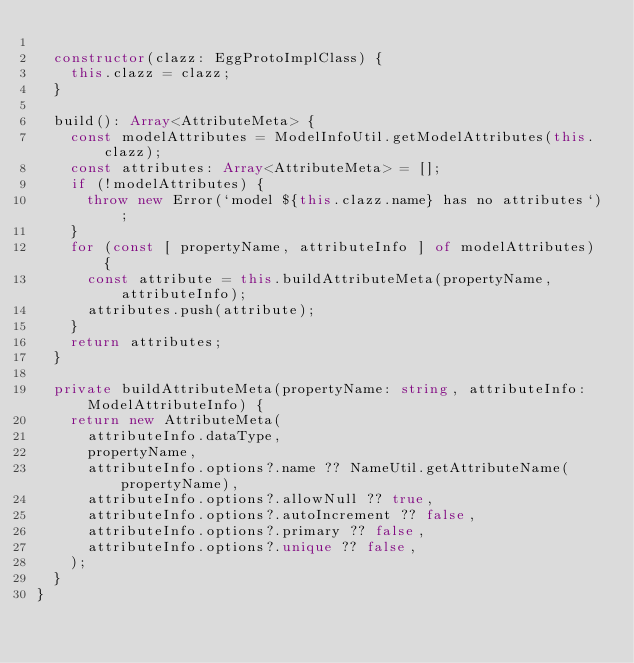<code> <loc_0><loc_0><loc_500><loc_500><_TypeScript_>
  constructor(clazz: EggProtoImplClass) {
    this.clazz = clazz;
  }

  build(): Array<AttributeMeta> {
    const modelAttributes = ModelInfoUtil.getModelAttributes(this.clazz);
    const attributes: Array<AttributeMeta> = [];
    if (!modelAttributes) {
      throw new Error(`model ${this.clazz.name} has no attributes`);
    }
    for (const [ propertyName, attributeInfo ] of modelAttributes) {
      const attribute = this.buildAttributeMeta(propertyName, attributeInfo);
      attributes.push(attribute);
    }
    return attributes;
  }

  private buildAttributeMeta(propertyName: string, attributeInfo: ModelAttributeInfo) {
    return new AttributeMeta(
      attributeInfo.dataType,
      propertyName,
      attributeInfo.options?.name ?? NameUtil.getAttributeName(propertyName),
      attributeInfo.options?.allowNull ?? true,
      attributeInfo.options?.autoIncrement ?? false,
      attributeInfo.options?.primary ?? false,
      attributeInfo.options?.unique ?? false,
    );
  }
}
</code> 